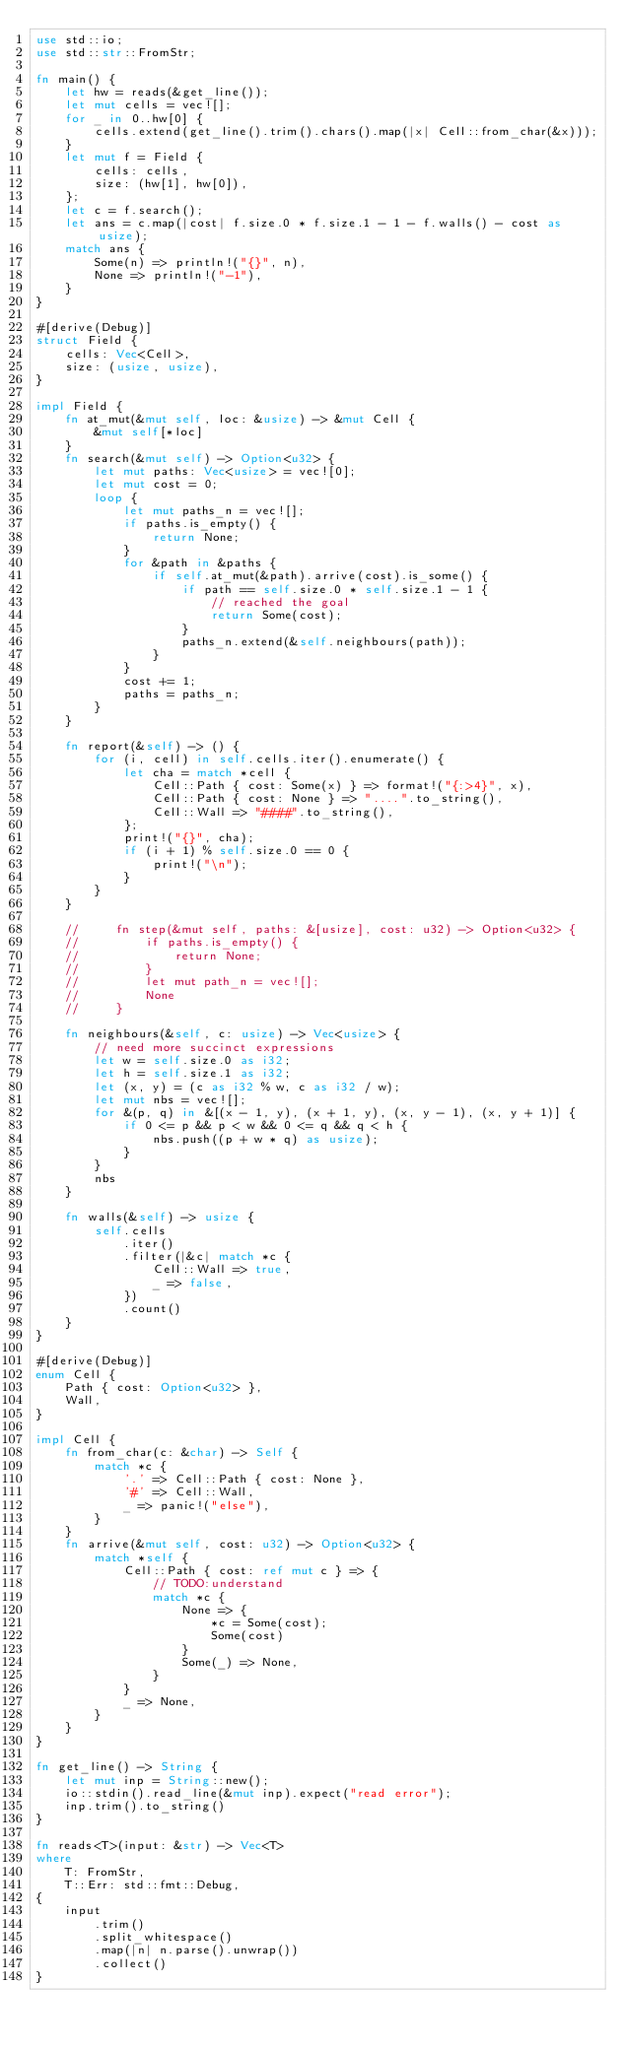<code> <loc_0><loc_0><loc_500><loc_500><_Rust_>use std::io;
use std::str::FromStr;

fn main() {
    let hw = reads(&get_line());
    let mut cells = vec![];
    for _ in 0..hw[0] {
        cells.extend(get_line().trim().chars().map(|x| Cell::from_char(&x)));
    }
    let mut f = Field {
        cells: cells,
        size: (hw[1], hw[0]),
    };
    let c = f.search();
    let ans = c.map(|cost| f.size.0 * f.size.1 - 1 - f.walls() - cost as usize);
    match ans {
        Some(n) => println!("{}", n),
        None => println!("-1"),
    }
}

#[derive(Debug)]
struct Field {
    cells: Vec<Cell>,
    size: (usize, usize),
}

impl Field {
    fn at_mut(&mut self, loc: &usize) -> &mut Cell {
        &mut self[*loc]
    }
    fn search(&mut self) -> Option<u32> {
        let mut paths: Vec<usize> = vec![0];
        let mut cost = 0;
        loop {
            let mut paths_n = vec![];
            if paths.is_empty() {
                return None;
            }
            for &path in &paths {
                if self.at_mut(&path).arrive(cost).is_some() {
                    if path == self.size.0 * self.size.1 - 1 {
                        // reached the goal
                        return Some(cost);
                    }
                    paths_n.extend(&self.neighbours(path));
                }
            }
            cost += 1;
            paths = paths_n;
        }
    }

    fn report(&self) -> () {
        for (i, cell) in self.cells.iter().enumerate() {
            let cha = match *cell {
                Cell::Path { cost: Some(x) } => format!("{:>4}", x),
                Cell::Path { cost: None } => "....".to_string(),
                Cell::Wall => "####".to_string(),
            };
            print!("{}", cha);
            if (i + 1) % self.size.0 == 0 {
                print!("\n");
            }
        }
    }

    //     fn step(&mut self, paths: &[usize], cost: u32) -> Option<u32> {
    //         if paths.is_empty() {
    //             return None;
    //         }
    //         let mut path_n = vec![];
    //         None
    //     }

    fn neighbours(&self, c: usize) -> Vec<usize> {
        // need more succinct expressions
        let w = self.size.0 as i32;
        let h = self.size.1 as i32;
        let (x, y) = (c as i32 % w, c as i32 / w);
        let mut nbs = vec![];
        for &(p, q) in &[(x - 1, y), (x + 1, y), (x, y - 1), (x, y + 1)] {
            if 0 <= p && p < w && 0 <= q && q < h {
                nbs.push((p + w * q) as usize);
            }
        }
        nbs
    }

    fn walls(&self) -> usize {
        self.cells
            .iter()
            .filter(|&c| match *c {
                Cell::Wall => true,
                _ => false,
            })
            .count()
    }
}

#[derive(Debug)]
enum Cell {
    Path { cost: Option<u32> },
    Wall,
}

impl Cell {
    fn from_char(c: &char) -> Self {
        match *c {
            '.' => Cell::Path { cost: None },
            '#' => Cell::Wall,
            _ => panic!("else"),
        }
    }
    fn arrive(&mut self, cost: u32) -> Option<u32> {
        match *self {
            Cell::Path { cost: ref mut c } => {
                // TODO:understand
                match *c {
                    None => {
                        *c = Some(cost);
                        Some(cost)
                    }
                    Some(_) => None,
                }
            }
            _ => None,
        }
    }
}

fn get_line() -> String {
    let mut inp = String::new();
    io::stdin().read_line(&mut inp).expect("read error");
    inp.trim().to_string()
}

fn reads<T>(input: &str) -> Vec<T>
where
    T: FromStr,
    T::Err: std::fmt::Debug,
{
    input
        .trim()
        .split_whitespace()
        .map(|n| n.parse().unwrap())
        .collect()
}
</code> 